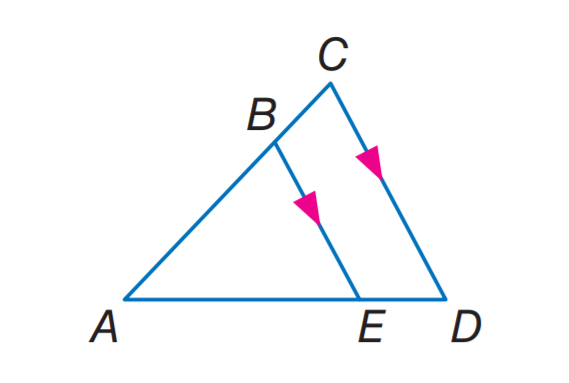Answer the mathemtical geometry problem and directly provide the correct option letter.
Question: If A D = 27, A B = 8, and A E = 12, find B C.
Choices: A: 8 B: 10 C: 12 D: 13.5 B 